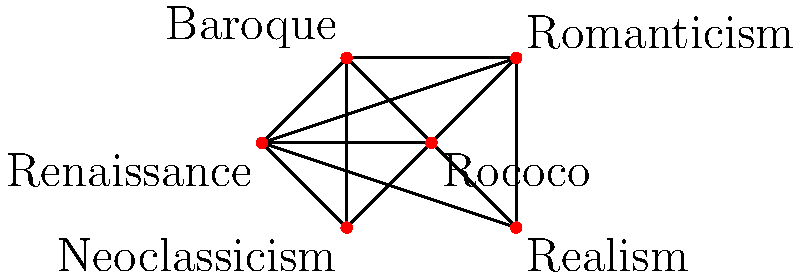In a virtual art gallery, you need to assign display areas to different art styles while ensuring that adjacent areas don't feature similar styles. The graph represents the relationships between art styles, where connected nodes indicate styles that shouldn't be placed in adjacent areas. What is the minimum number of distinct display areas (represented by colors in graph coloring) needed to properly arrange all the art styles? To solve this graph coloring problem, we'll use the following steps:

1. Identify the vertices: Each vertex represents an art style (Renaissance, Baroque, Rococo, Neoclassicism, Romanticism, and Realism).

2. Analyze the edges: Connected vertices cannot have the same color (display area).

3. Apply the greedy coloring algorithm:
   a. Start with Renaissance (arbitrary choice) and assign it color 1.
   b. Move to Baroque: It's connected to Renaissance, so assign color 2.
   c. Rococo: Connected to Renaissance and Baroque, assign color 3.
   d. Neoclassicism: Connected to Renaissance, Baroque, and Rococo, assign color 4.
   e. Romanticism: Connected to all previous styles, assign color 5.
   f. Realism: Connected to all styles except Neoclassicism. Can use color 4.

4. Count the number of distinct colors used: 5 colors were needed.

5. Verify that no adjacent vertices have the same color.

The minimum number of colors (display areas) needed is 5, which is also equal to the chromatic number $\chi(G)$ of this graph.
Answer: 5 